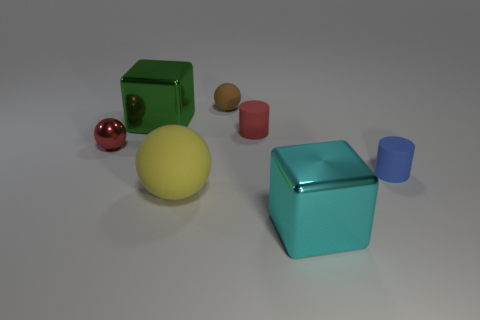Add 2 small gray metal objects. How many objects exist? 9 Subtract all spheres. How many objects are left? 4 Add 2 yellow matte things. How many yellow matte things are left? 3 Add 5 tiny blue objects. How many tiny blue objects exist? 6 Subtract 0 purple cubes. How many objects are left? 7 Subtract all small blue rubber cylinders. Subtract all red metallic objects. How many objects are left? 5 